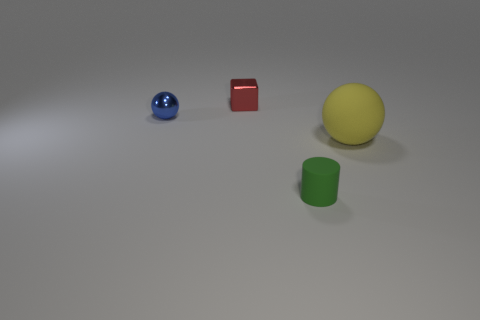Add 2 small cyan objects. How many objects exist? 6 Subtract 0 green cubes. How many objects are left? 4 Subtract all blocks. How many objects are left? 3 Subtract all tiny spheres. Subtract all tiny red metallic things. How many objects are left? 2 Add 4 shiny objects. How many shiny objects are left? 6 Add 4 red metallic things. How many red metallic things exist? 5 